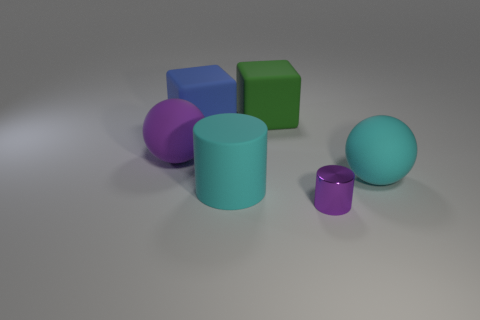Add 1 blue things. How many objects exist? 7 Subtract all cubes. How many objects are left? 4 Subtract 0 purple cubes. How many objects are left? 6 Subtract all large blue cubes. Subtract all tiny purple cylinders. How many objects are left? 4 Add 3 rubber blocks. How many rubber blocks are left? 5 Add 1 cyan things. How many cyan things exist? 3 